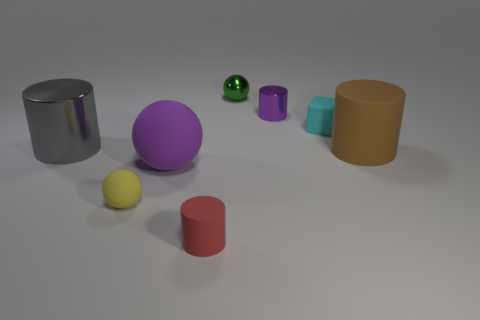Add 2 large brown things. How many objects exist? 10 Subtract all cubes. How many objects are left? 7 Subtract all purple metal blocks. Subtract all cylinders. How many objects are left? 4 Add 4 big purple balls. How many big purple balls are left? 5 Add 7 purple matte things. How many purple matte things exist? 8 Subtract 0 brown spheres. How many objects are left? 8 